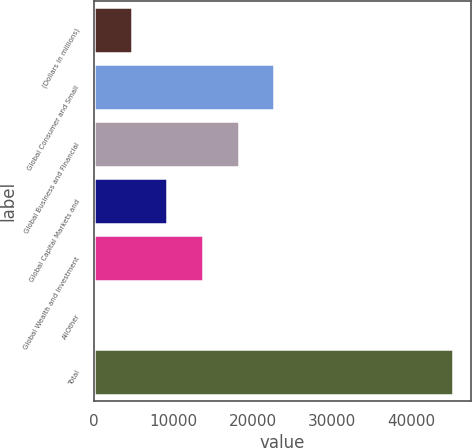<chart> <loc_0><loc_0><loc_500><loc_500><bar_chart><fcel>(Dollars in millions)<fcel>Global Consumer and Small<fcel>Global Business and Financial<fcel>Global Capital Markets and<fcel>Global Wealth and Investment<fcel>AllOther<fcel>Total<nl><fcel>4763.8<fcel>22763<fcel>18263.2<fcel>9263.6<fcel>13763.4<fcel>264<fcel>45262<nl></chart> 